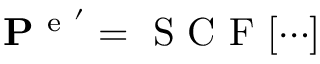Convert formula to latex. <formula><loc_0><loc_0><loc_500><loc_500>P ^ { e ^ { \prime } } = S C F [ \cdots ]</formula> 